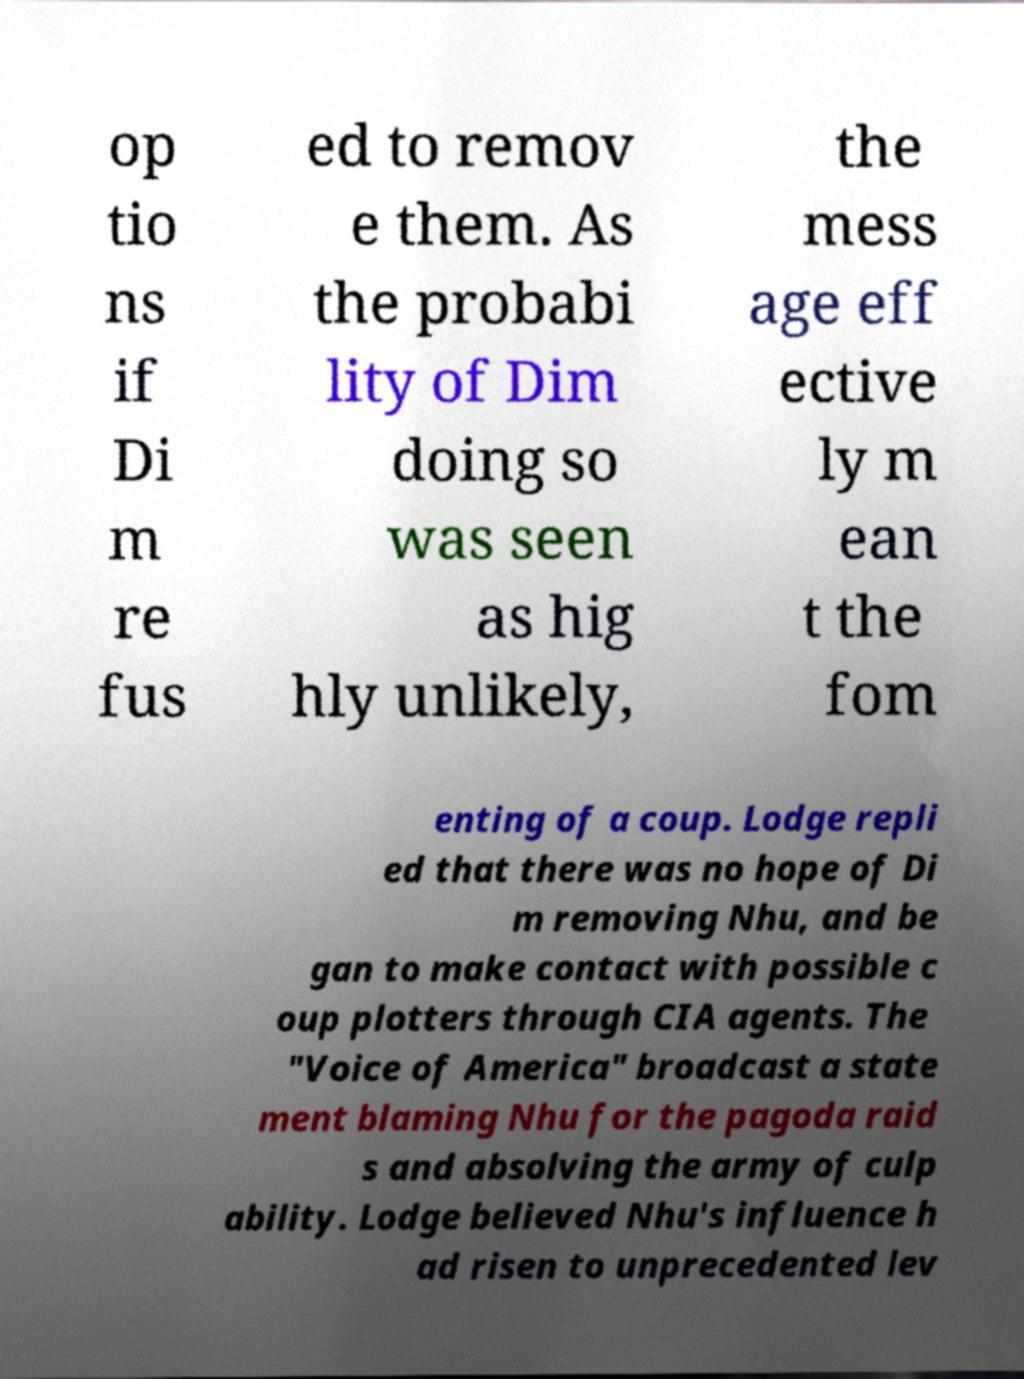I need the written content from this picture converted into text. Can you do that? op tio ns if Di m re fus ed to remov e them. As the probabi lity of Dim doing so was seen as hig hly unlikely, the mess age eff ective ly m ean t the fom enting of a coup. Lodge repli ed that there was no hope of Di m removing Nhu, and be gan to make contact with possible c oup plotters through CIA agents. The "Voice of America" broadcast a state ment blaming Nhu for the pagoda raid s and absolving the army of culp ability. Lodge believed Nhu's influence h ad risen to unprecedented lev 